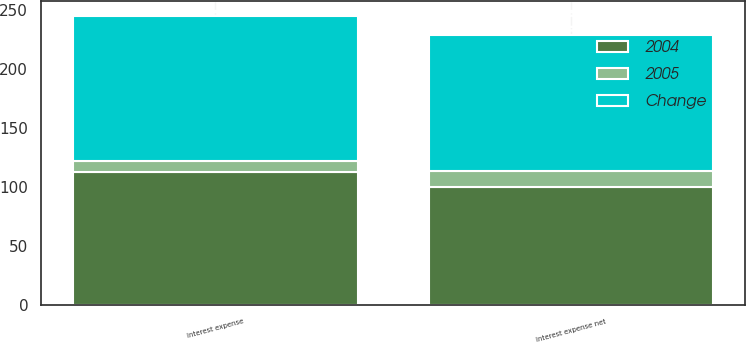Convert chart to OTSL. <chart><loc_0><loc_0><loc_500><loc_500><stacked_bar_chart><ecel><fcel>Interest expense<fcel>Interest expense net<nl><fcel>2004<fcel>113<fcel>100<nl><fcel>Change<fcel>123<fcel>115<nl><fcel>2005<fcel>9<fcel>14<nl></chart> 